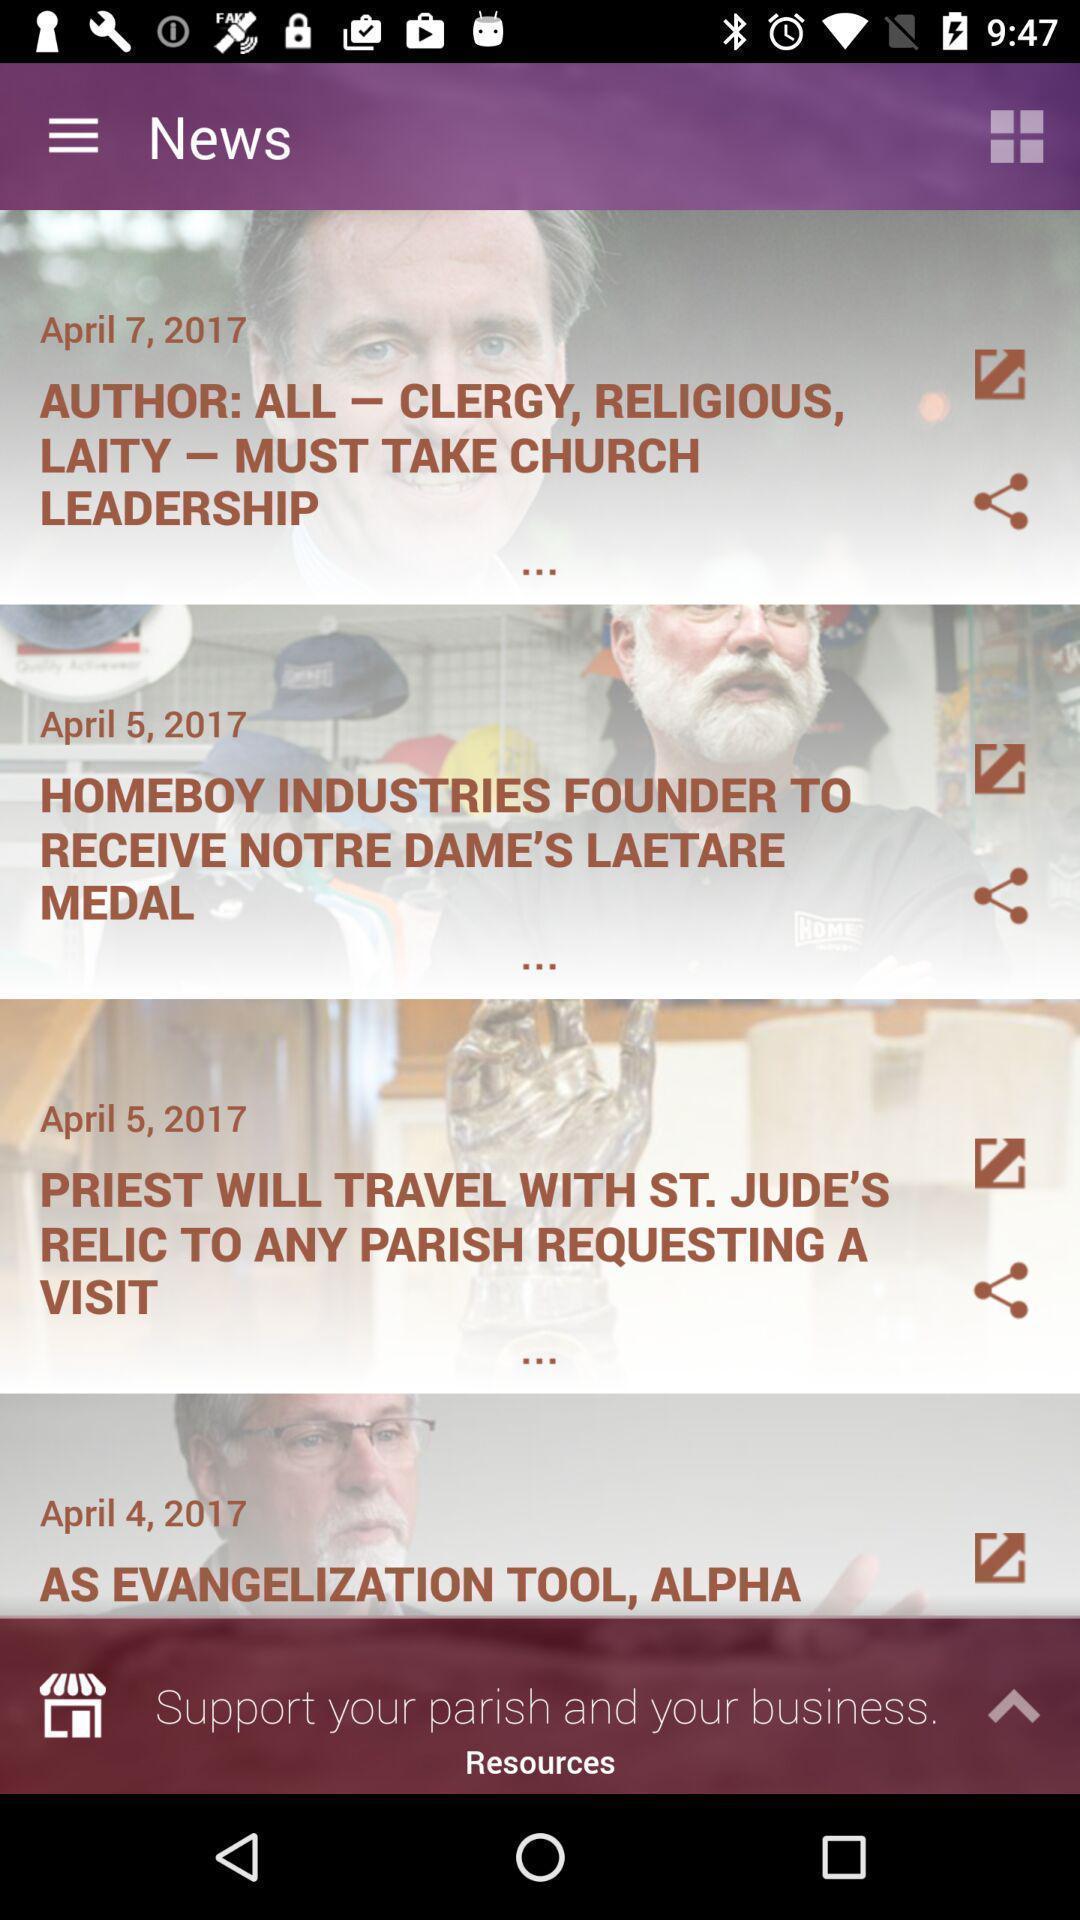Provide a textual representation of this image. Page displaying events in religious place app. 